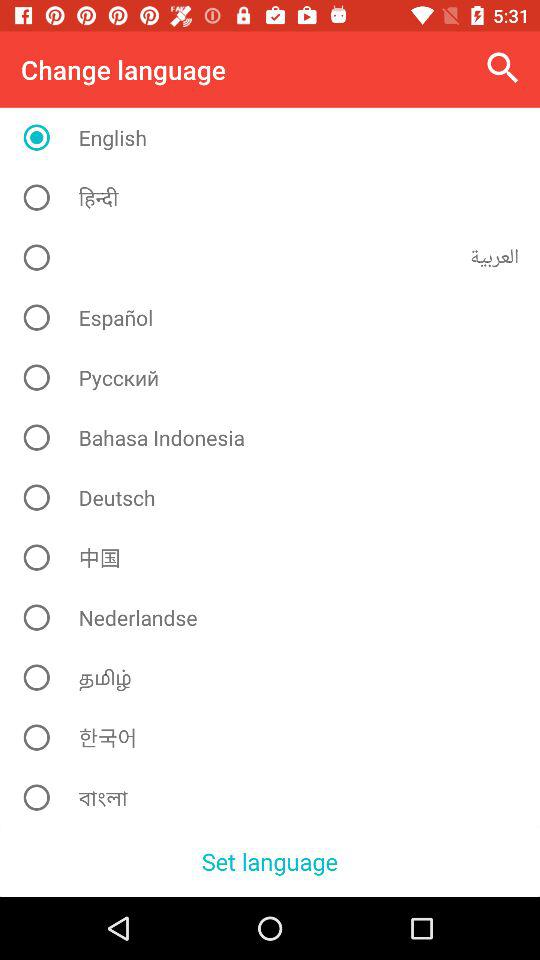Is "Nederlandse" selected or not? "Nederlandse" is not selected. 